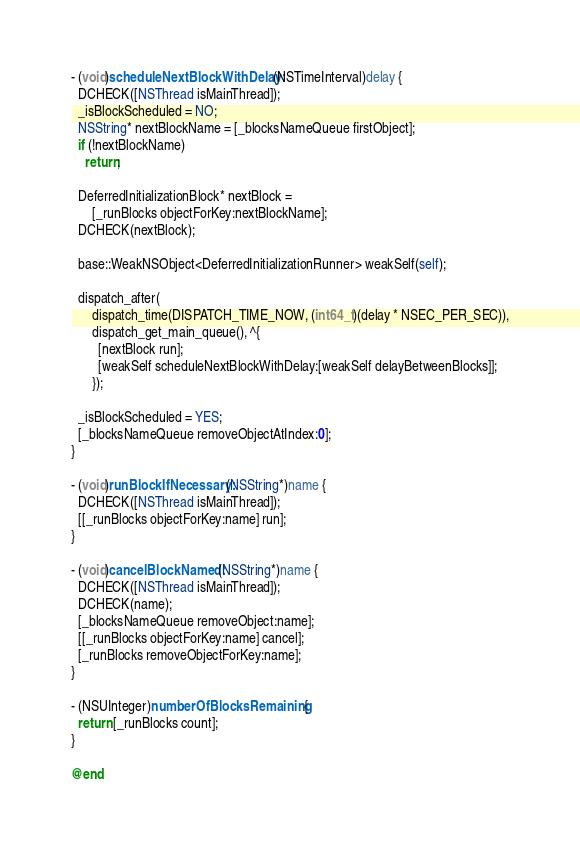Convert code to text. <code><loc_0><loc_0><loc_500><loc_500><_ObjectiveC_>
- (void)scheduleNextBlockWithDelay:(NSTimeInterval)delay {
  DCHECK([NSThread isMainThread]);
  _isBlockScheduled = NO;
  NSString* nextBlockName = [_blocksNameQueue firstObject];
  if (!nextBlockName)
    return;

  DeferredInitializationBlock* nextBlock =
      [_runBlocks objectForKey:nextBlockName];
  DCHECK(nextBlock);

  base::WeakNSObject<DeferredInitializationRunner> weakSelf(self);

  dispatch_after(
      dispatch_time(DISPATCH_TIME_NOW, (int64_t)(delay * NSEC_PER_SEC)),
      dispatch_get_main_queue(), ^{
        [nextBlock run];
        [weakSelf scheduleNextBlockWithDelay:[weakSelf delayBetweenBlocks]];
      });

  _isBlockScheduled = YES;
  [_blocksNameQueue removeObjectAtIndex:0];
}

- (void)runBlockIfNecessary:(NSString*)name {
  DCHECK([NSThread isMainThread]);
  [[_runBlocks objectForKey:name] run];
}

- (void)cancelBlockNamed:(NSString*)name {
  DCHECK([NSThread isMainThread]);
  DCHECK(name);
  [_blocksNameQueue removeObject:name];
  [[_runBlocks objectForKey:name] cancel];
  [_runBlocks removeObjectForKey:name];
}

- (NSUInteger)numberOfBlocksRemaining {
  return [_runBlocks count];
}

@end
</code> 